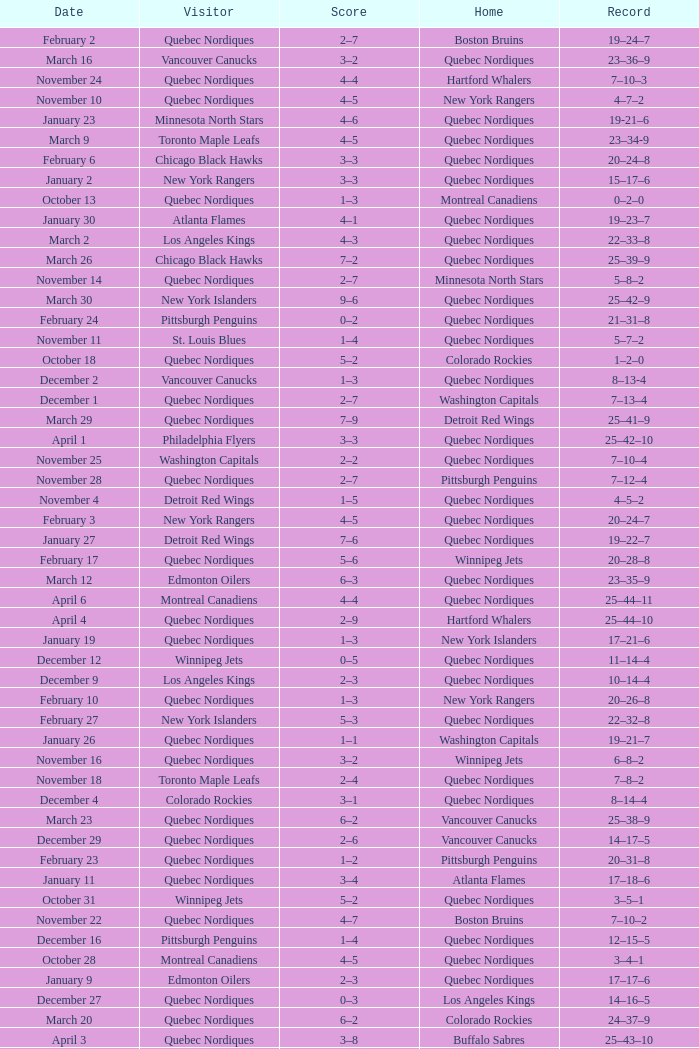Which Home has a Record of 16–17–6? Toronto Maple Leafs. 